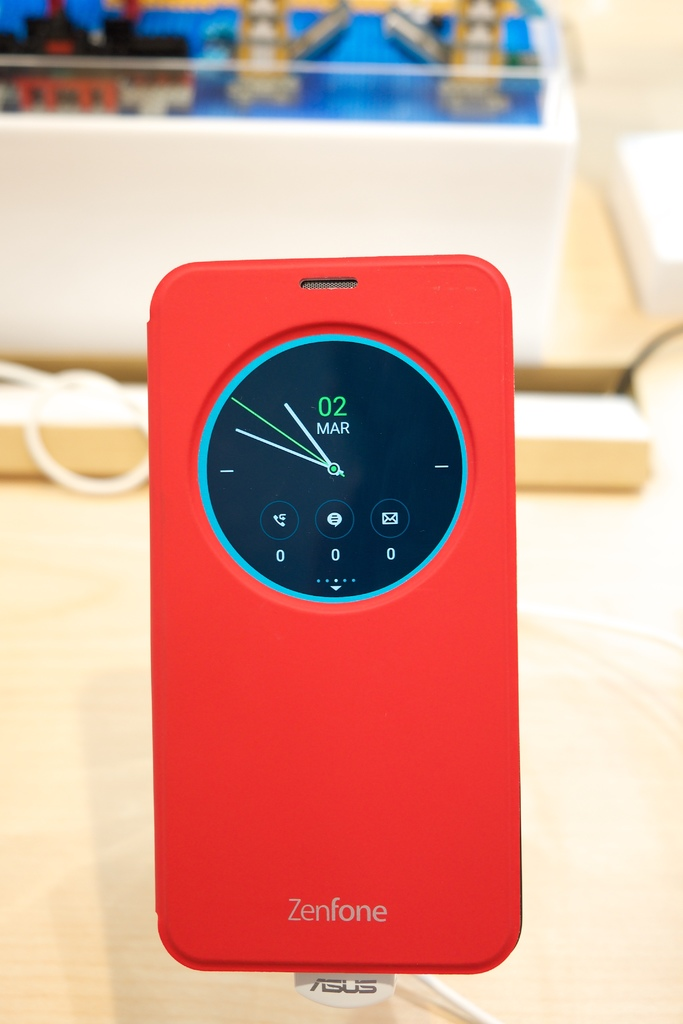How does the distinctive color and design of this phone case contribute to aesthetic or branding? The vivid red color not only grabs attention but also aligns with ASUS's branding, which often emphasizes bold, striking designs that appeal to a youthful, tech-savvy audience looking for functionality wrapped in standout aesthetics. 